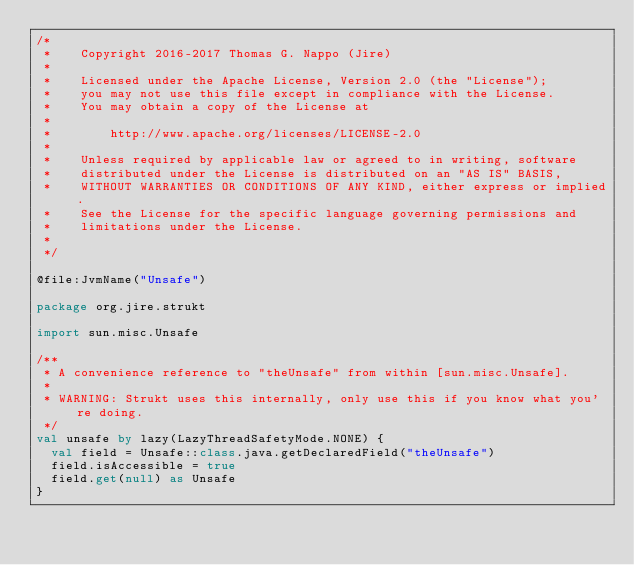<code> <loc_0><loc_0><loc_500><loc_500><_Kotlin_>/*
 *    Copyright 2016-2017 Thomas G. Nappo (Jire)
 *
 *    Licensed under the Apache License, Version 2.0 (the "License");
 *    you may not use this file except in compliance with the License.
 *    You may obtain a copy of the License at
 *
 *        http://www.apache.org/licenses/LICENSE-2.0
 *
 *    Unless required by applicable law or agreed to in writing, software
 *    distributed under the License is distributed on an "AS IS" BASIS,
 *    WITHOUT WARRANTIES OR CONDITIONS OF ANY KIND, either express or implied.
 *    See the License for the specific language governing permissions and
 *    limitations under the License.
 *
 */

@file:JvmName("Unsafe")

package org.jire.strukt

import sun.misc.Unsafe

/**
 * A convenience reference to "theUnsafe" from within [sun.misc.Unsafe].
 *
 * WARNING: Strukt uses this internally, only use this if you know what you're doing.
 */
val unsafe by lazy(LazyThreadSafetyMode.NONE) {
	val field = Unsafe::class.java.getDeclaredField("theUnsafe")
	field.isAccessible = true
	field.get(null) as Unsafe
}</code> 